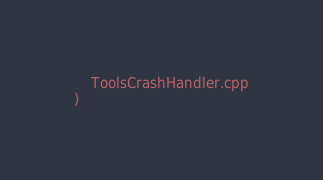<code> <loc_0><loc_0><loc_500><loc_500><_CMake_>    ToolsCrashHandler.cpp
)
</code> 